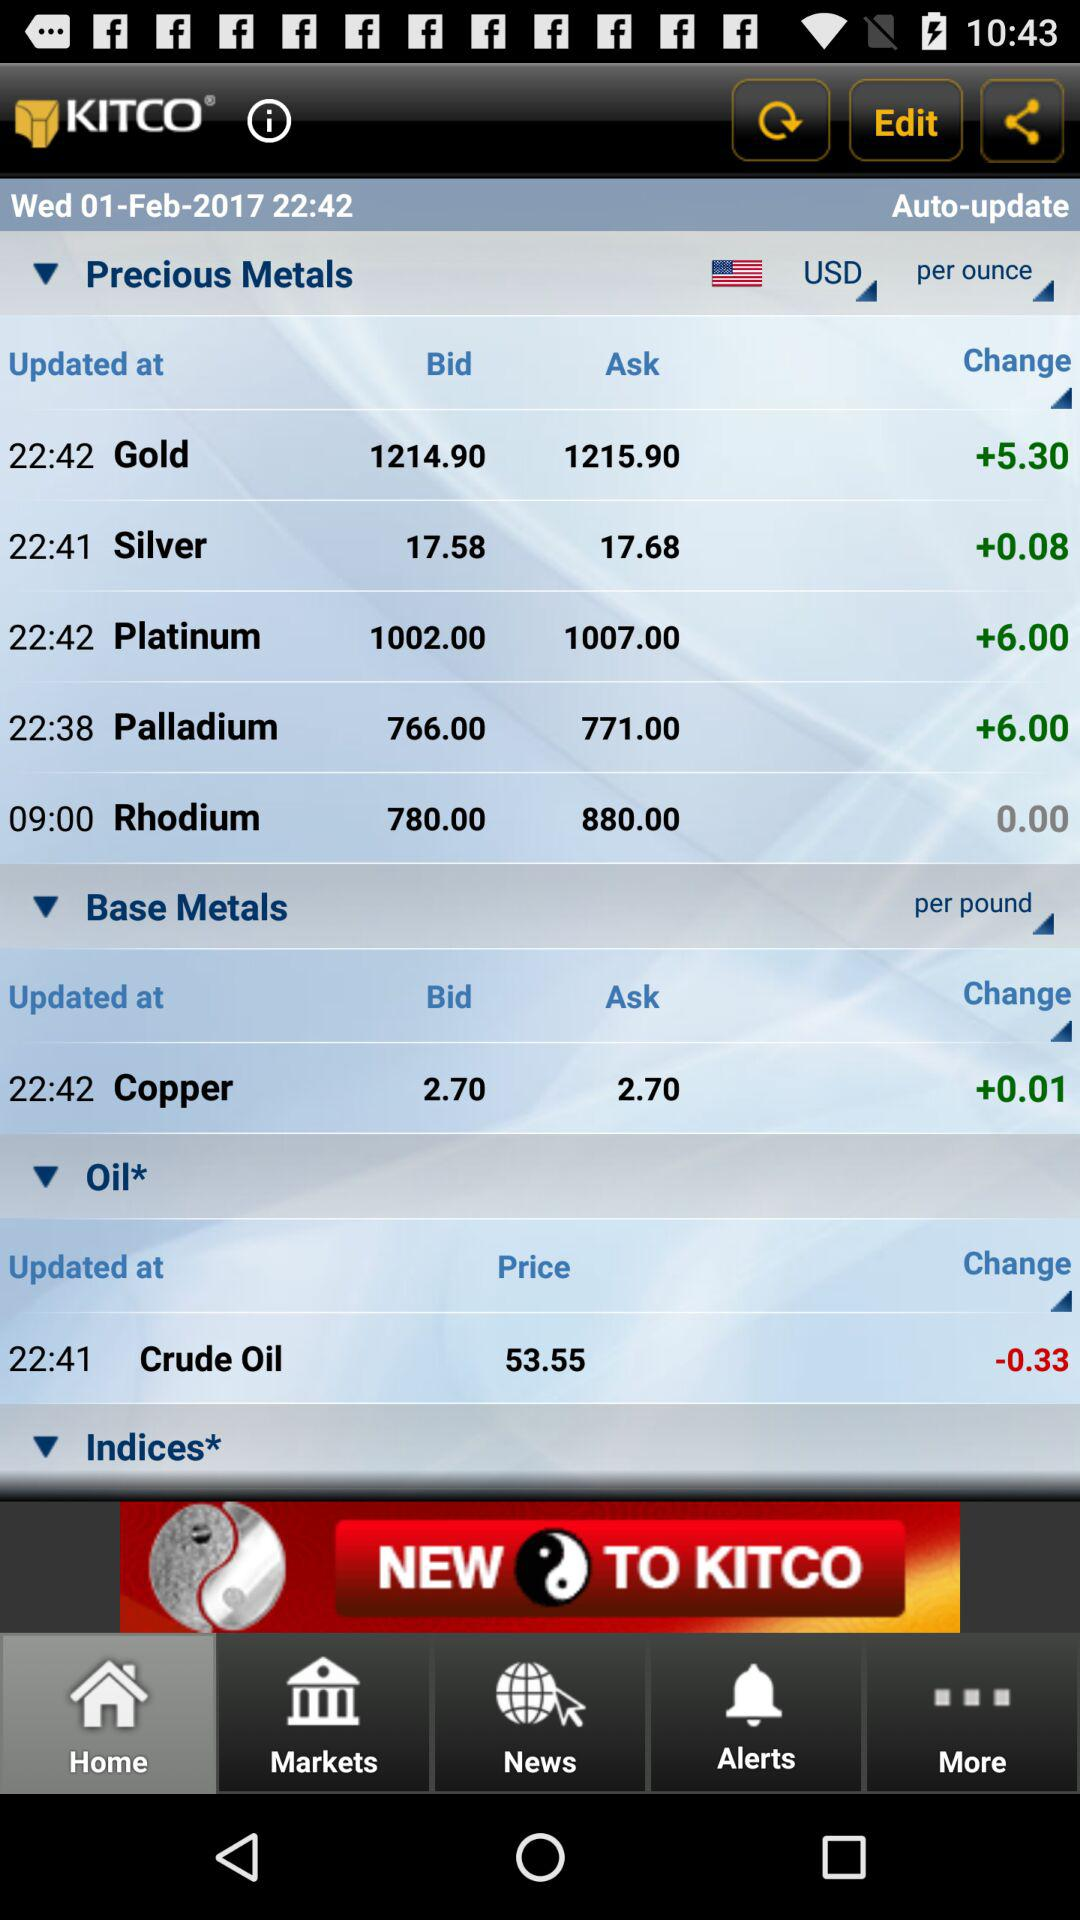Which tab is selected? The selected tab is "Home". 